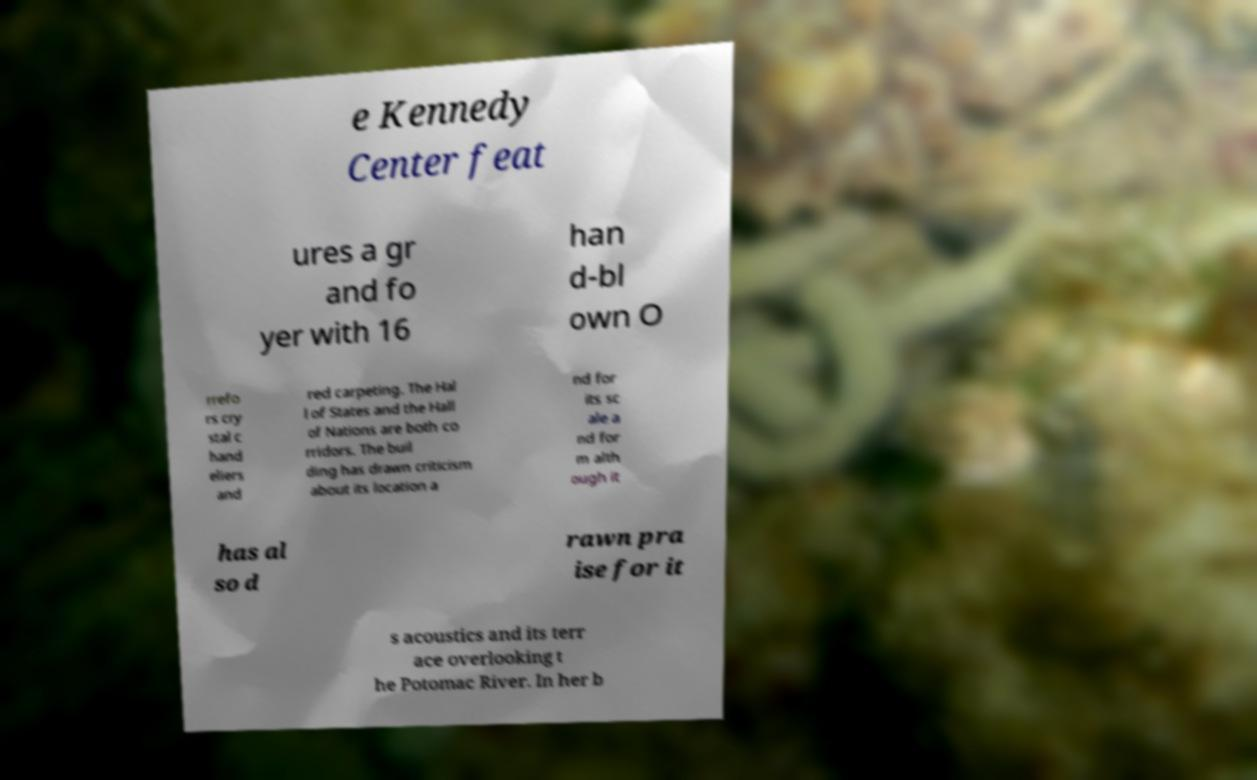For documentation purposes, I need the text within this image transcribed. Could you provide that? e Kennedy Center feat ures a gr and fo yer with 16 han d-bl own O rrefo rs cry stal c hand eliers and red carpeting. The Hal l of States and the Hall of Nations are both co rridors. The buil ding has drawn criticism about its location a nd for its sc ale a nd for m alth ough it has al so d rawn pra ise for it s acoustics and its terr ace overlooking t he Potomac River. In her b 